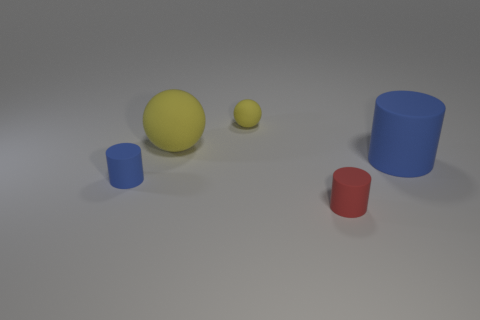What is the color of the large thing that is behind the matte object that is right of the red rubber cylinder?
Offer a terse response. Yellow. Is there a large cylinder of the same color as the large matte sphere?
Your answer should be very brief. No. What is the color of the other matte cylinder that is the same size as the red matte cylinder?
Make the answer very short. Blue. Is the material of the blue cylinder that is on the left side of the tiny red cylinder the same as the big cylinder?
Ensure brevity in your answer.  Yes. There is a small matte object that is behind the rubber thing that is on the right side of the tiny red object; are there any tiny things right of it?
Provide a succinct answer. Yes. There is a small rubber thing that is right of the tiny yellow matte object; is it the same shape as the big blue matte object?
Ensure brevity in your answer.  Yes. There is a small rubber object that is in front of the cylinder that is left of the red rubber thing; what is its shape?
Keep it short and to the point. Cylinder. There is a rubber thing that is right of the small rubber cylinder that is on the right side of the small blue object that is on the left side of the tiny yellow object; what size is it?
Provide a short and direct response. Large. The big matte object that is the same shape as the small blue object is what color?
Offer a terse response. Blue. There is a small blue thing that is in front of the large matte cylinder; what is it made of?
Keep it short and to the point. Rubber. 